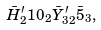Convert formula to latex. <formula><loc_0><loc_0><loc_500><loc_500>\bar { H } ^ { \prime } _ { 2 } 1 0 _ { 2 } \bar { Y } _ { 3 2 } ^ { \prime } \bar { 5 } _ { 3 } ,</formula> 